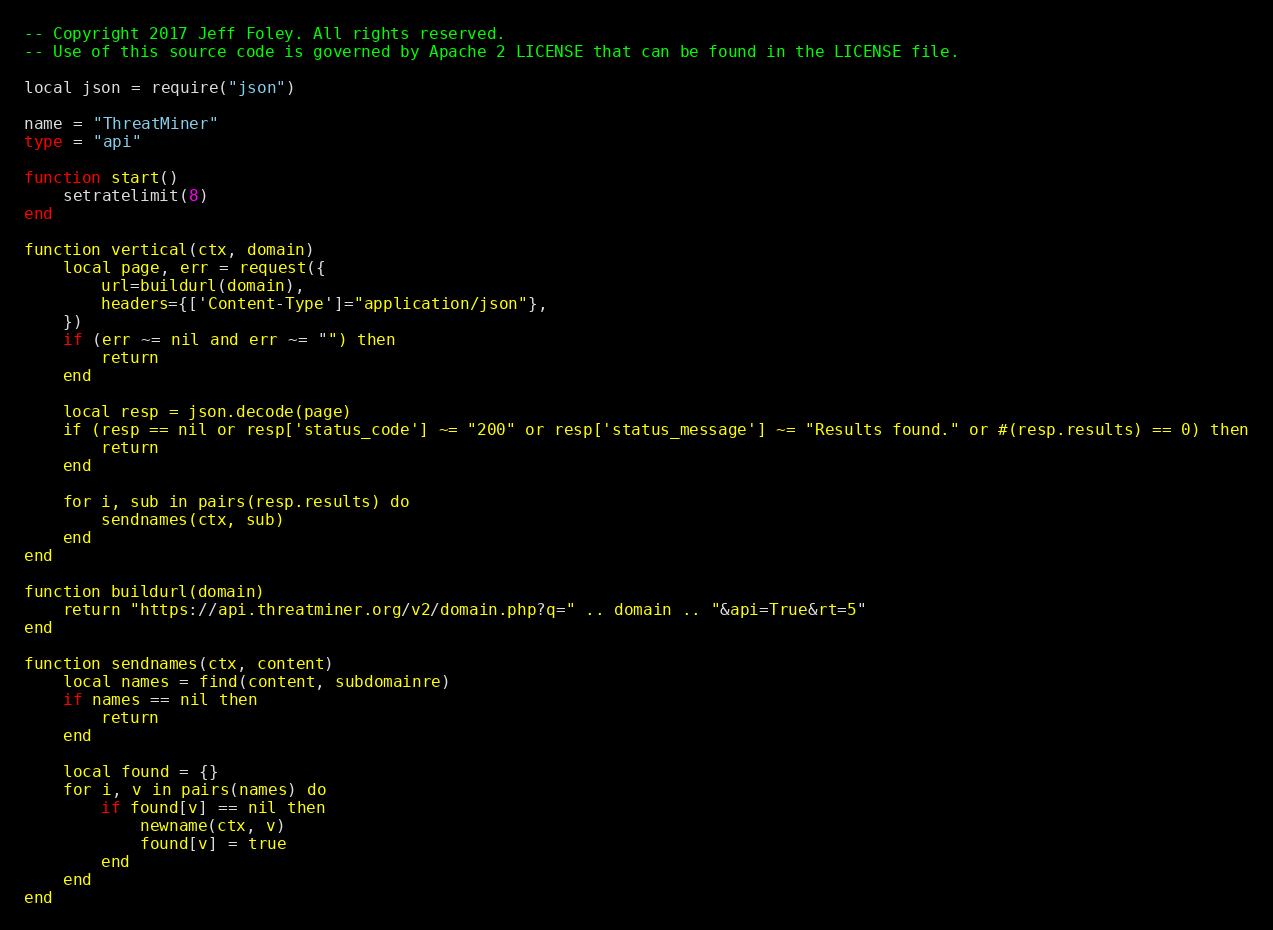<code> <loc_0><loc_0><loc_500><loc_500><_Ada_>-- Copyright 2017 Jeff Foley. All rights reserved.
-- Use of this source code is governed by Apache 2 LICENSE that can be found in the LICENSE file.

local json = require("json")

name = "ThreatMiner"
type = "api"

function start()
    setratelimit(8)
end

function vertical(ctx, domain)
    local page, err = request({
        url=buildurl(domain),
        headers={['Content-Type']="application/json"},
    })
    if (err ~= nil and err ~= "") then
        return
    end

    local resp = json.decode(page)
    if (resp == nil or resp['status_code'] ~= "200" or resp['status_message'] ~= "Results found." or #(resp.results) == 0) then
        return
    end

    for i, sub in pairs(resp.results) do
        sendnames(ctx, sub)
    end
end

function buildurl(domain)
    return "https://api.threatminer.org/v2/domain.php?q=" .. domain .. "&api=True&rt=5"
end

function sendnames(ctx, content)
    local names = find(content, subdomainre)
    if names == nil then
        return
    end

    local found = {}
    for i, v in pairs(names) do
        if found[v] == nil then
            newname(ctx, v)
            found[v] = true
        end
    end
end
</code> 